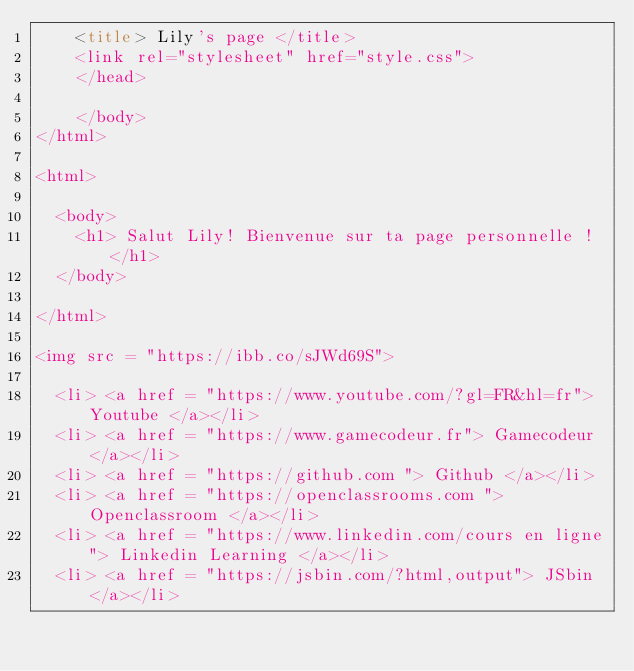Convert code to text. <code><loc_0><loc_0><loc_500><loc_500><_HTML_>    <title> Lily's page </title>
    <link rel="stylesheet" href="style.css">
    </head>
    
    </body>
</html>

<html>

  <body>
    <h1> Salut Lily! Bienvenue sur ta page personnelle ! </h1>
  </body>

</html>

<img src = "https://ibb.co/sJWd69S">

  <li> <a href = "https://www.youtube.com/?gl=FR&hl=fr"> Youtube </a></li>
  <li> <a href = "https://www.gamecodeur.fr"> Gamecodeur </a></li>
  <li> <a href = "https://github.com "> Github </a></li>
  <li> <a href = "https://openclassrooms.com "> Openclassroom </a></li>
  <li> <a href = "https://www.linkedin.com/cours en ligne"> Linkedin Learning </a></li> 
  <li> <a href = "https://jsbin.com/?html,output"> JSbin </a></li>
</code> 